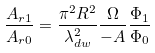<formula> <loc_0><loc_0><loc_500><loc_500>\frac { A _ { r 1 } } { A _ { r 0 } } = \frac { \pi ^ { 2 } R ^ { 2 } } { \lambda ^ { 2 } _ { d w } } \frac { \Omega } { - A } \frac { \Phi _ { 1 } } { \Phi _ { 0 } }</formula> 